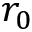Convert formula to latex. <formula><loc_0><loc_0><loc_500><loc_500>r _ { 0 }</formula> 